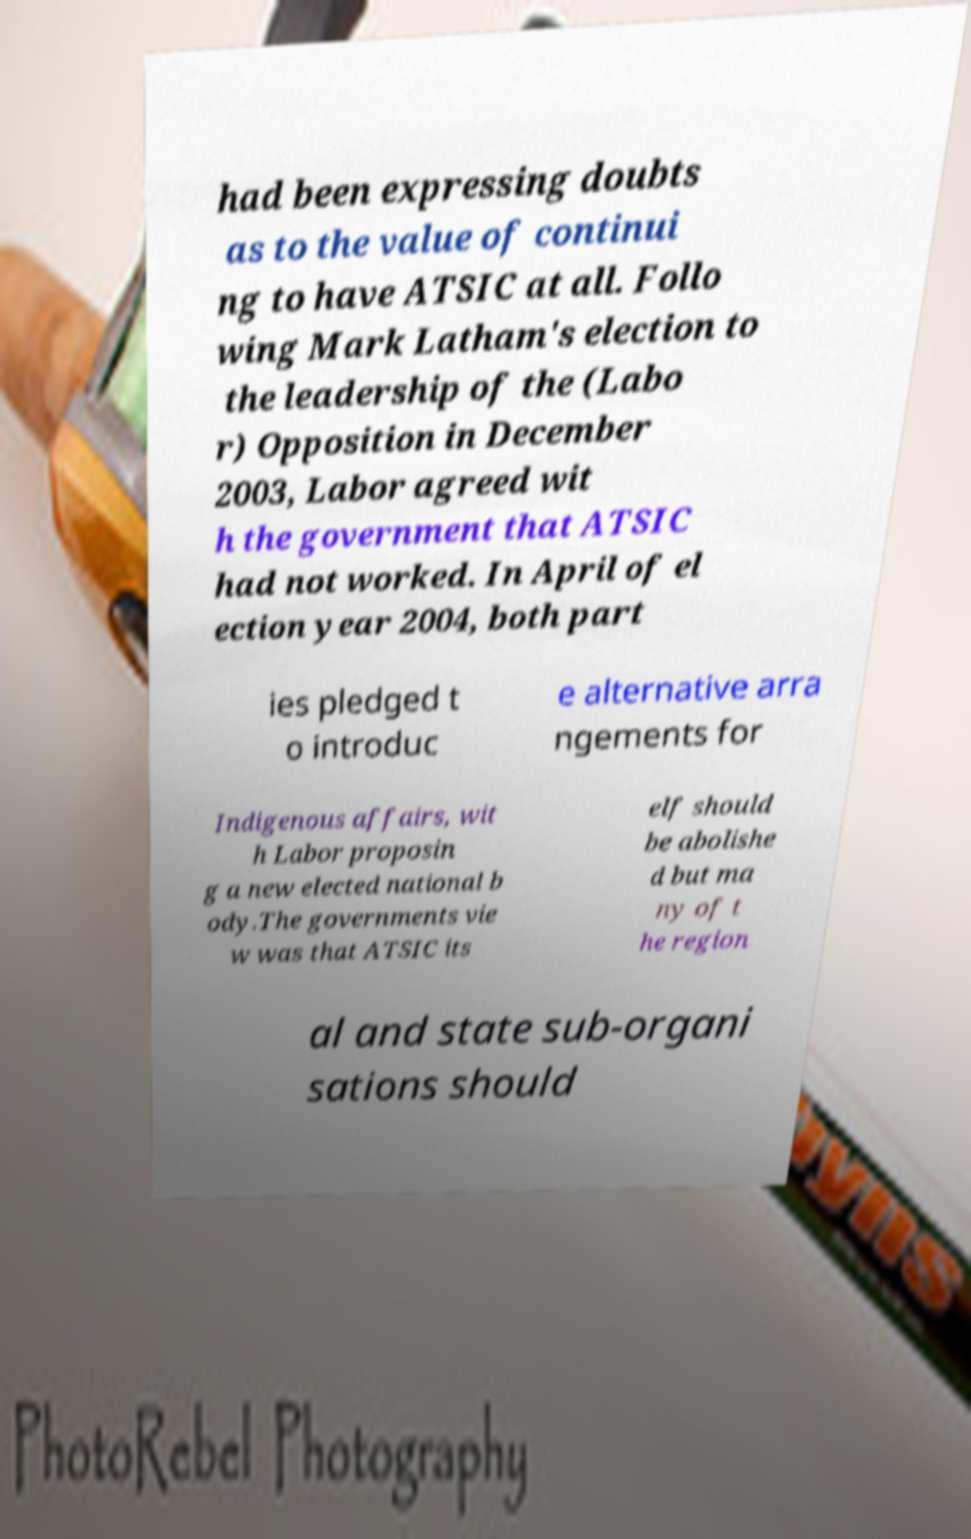I need the written content from this picture converted into text. Can you do that? had been expressing doubts as to the value of continui ng to have ATSIC at all. Follo wing Mark Latham's election to the leadership of the (Labo r) Opposition in December 2003, Labor agreed wit h the government that ATSIC had not worked. In April of el ection year 2004, both part ies pledged t o introduc e alternative arra ngements for Indigenous affairs, wit h Labor proposin g a new elected national b ody.The governments vie w was that ATSIC its elf should be abolishe d but ma ny of t he region al and state sub-organi sations should 